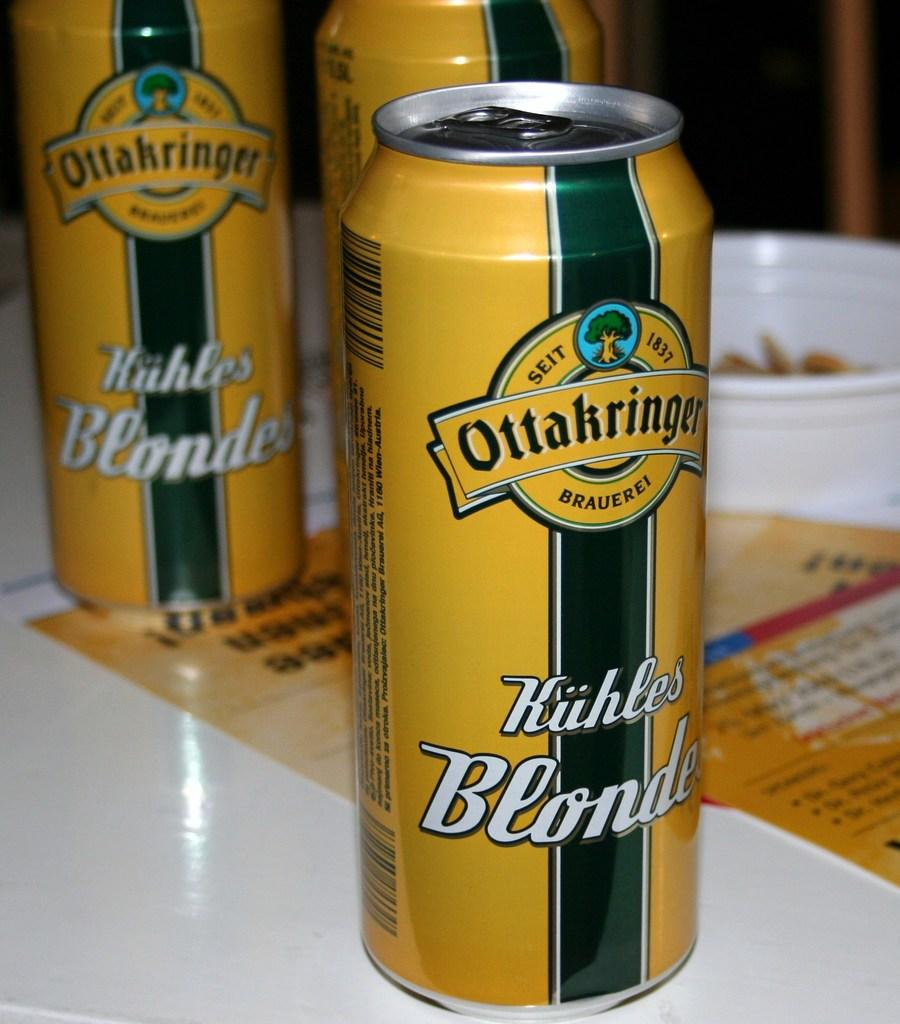<image>
Create a compact narrative representing the image presented. A yellow can of beer that reads Kuhles Blonde. 